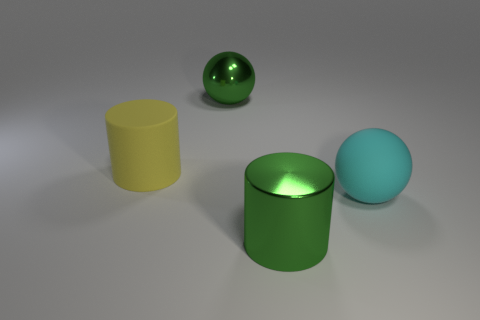Add 3 matte cylinders. How many objects exist? 7 Subtract all big green shiny cylinders. Subtract all large green metallic objects. How many objects are left? 1 Add 1 large cyan matte things. How many large cyan matte things are left? 2 Add 1 metal spheres. How many metal spheres exist? 2 Subtract 0 blue cubes. How many objects are left? 4 